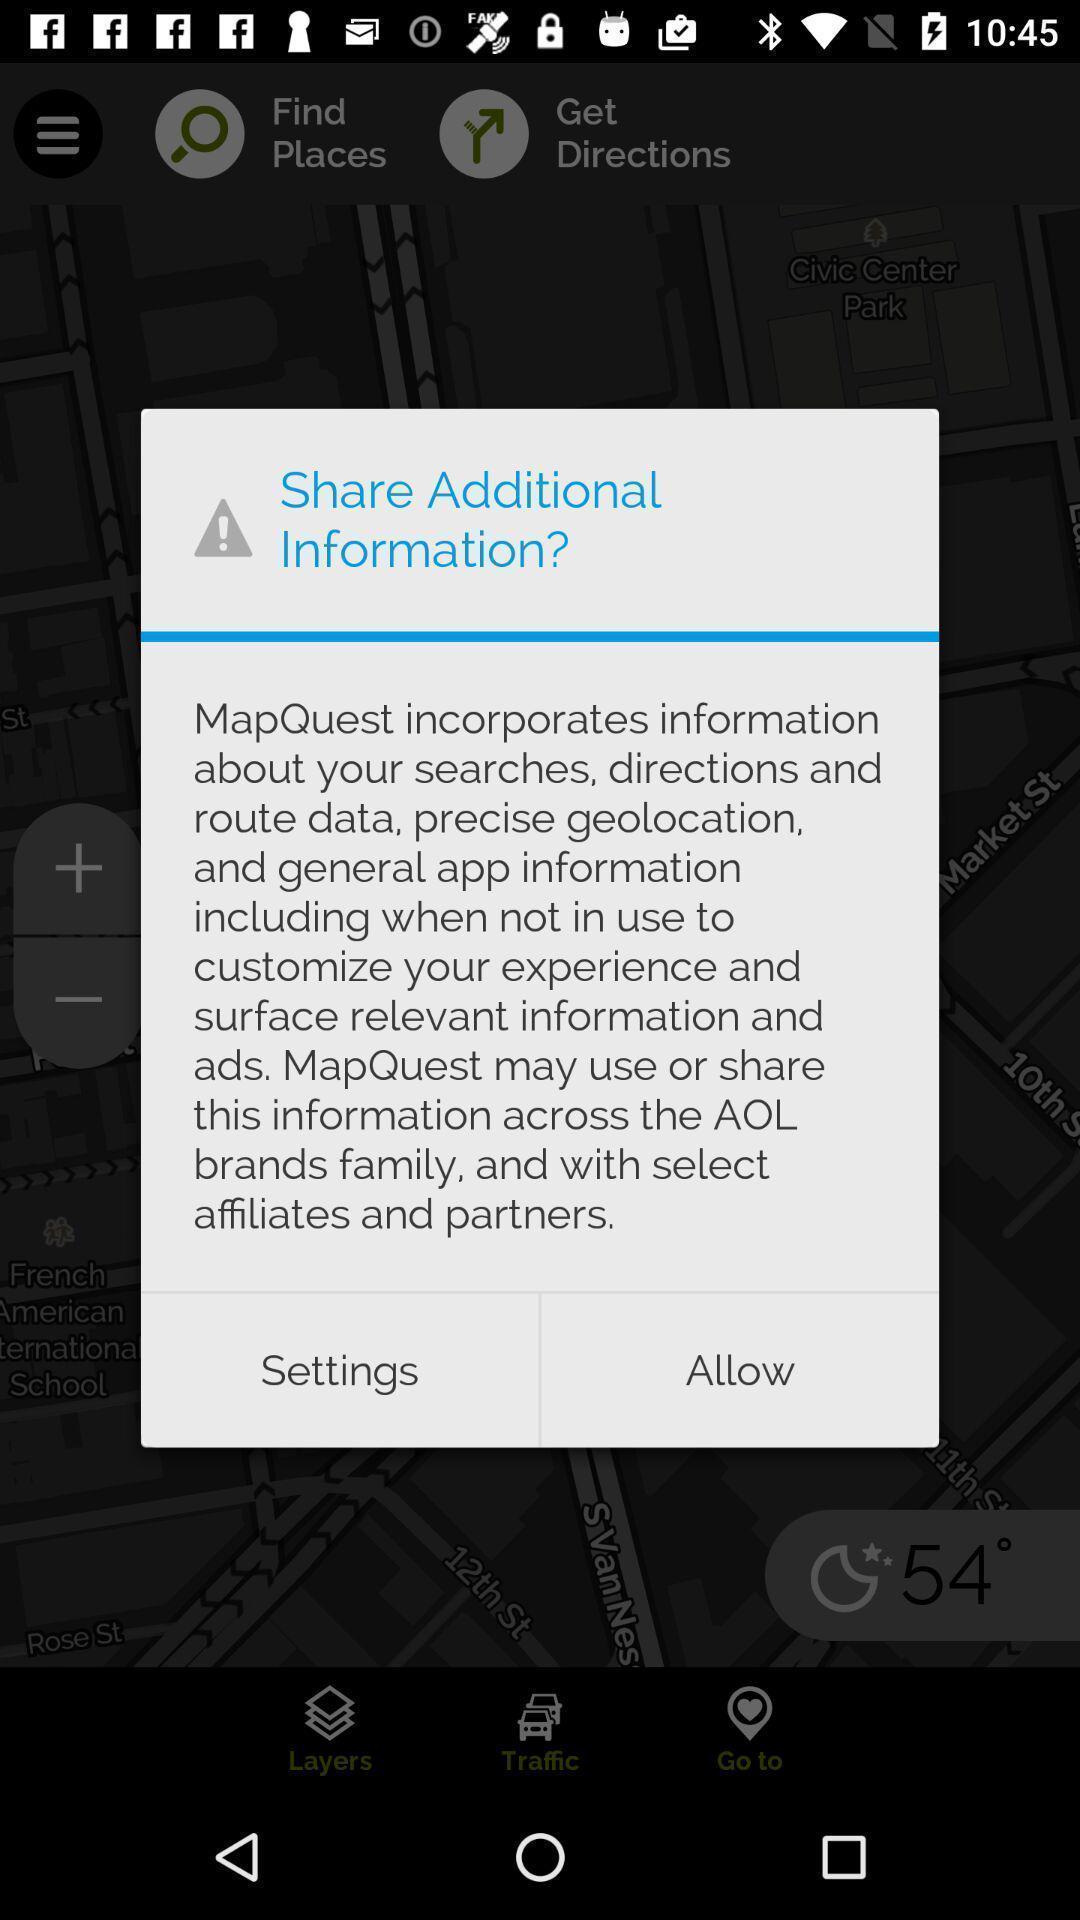Summarize the information in this screenshot. Popup showing settings and allow option. 